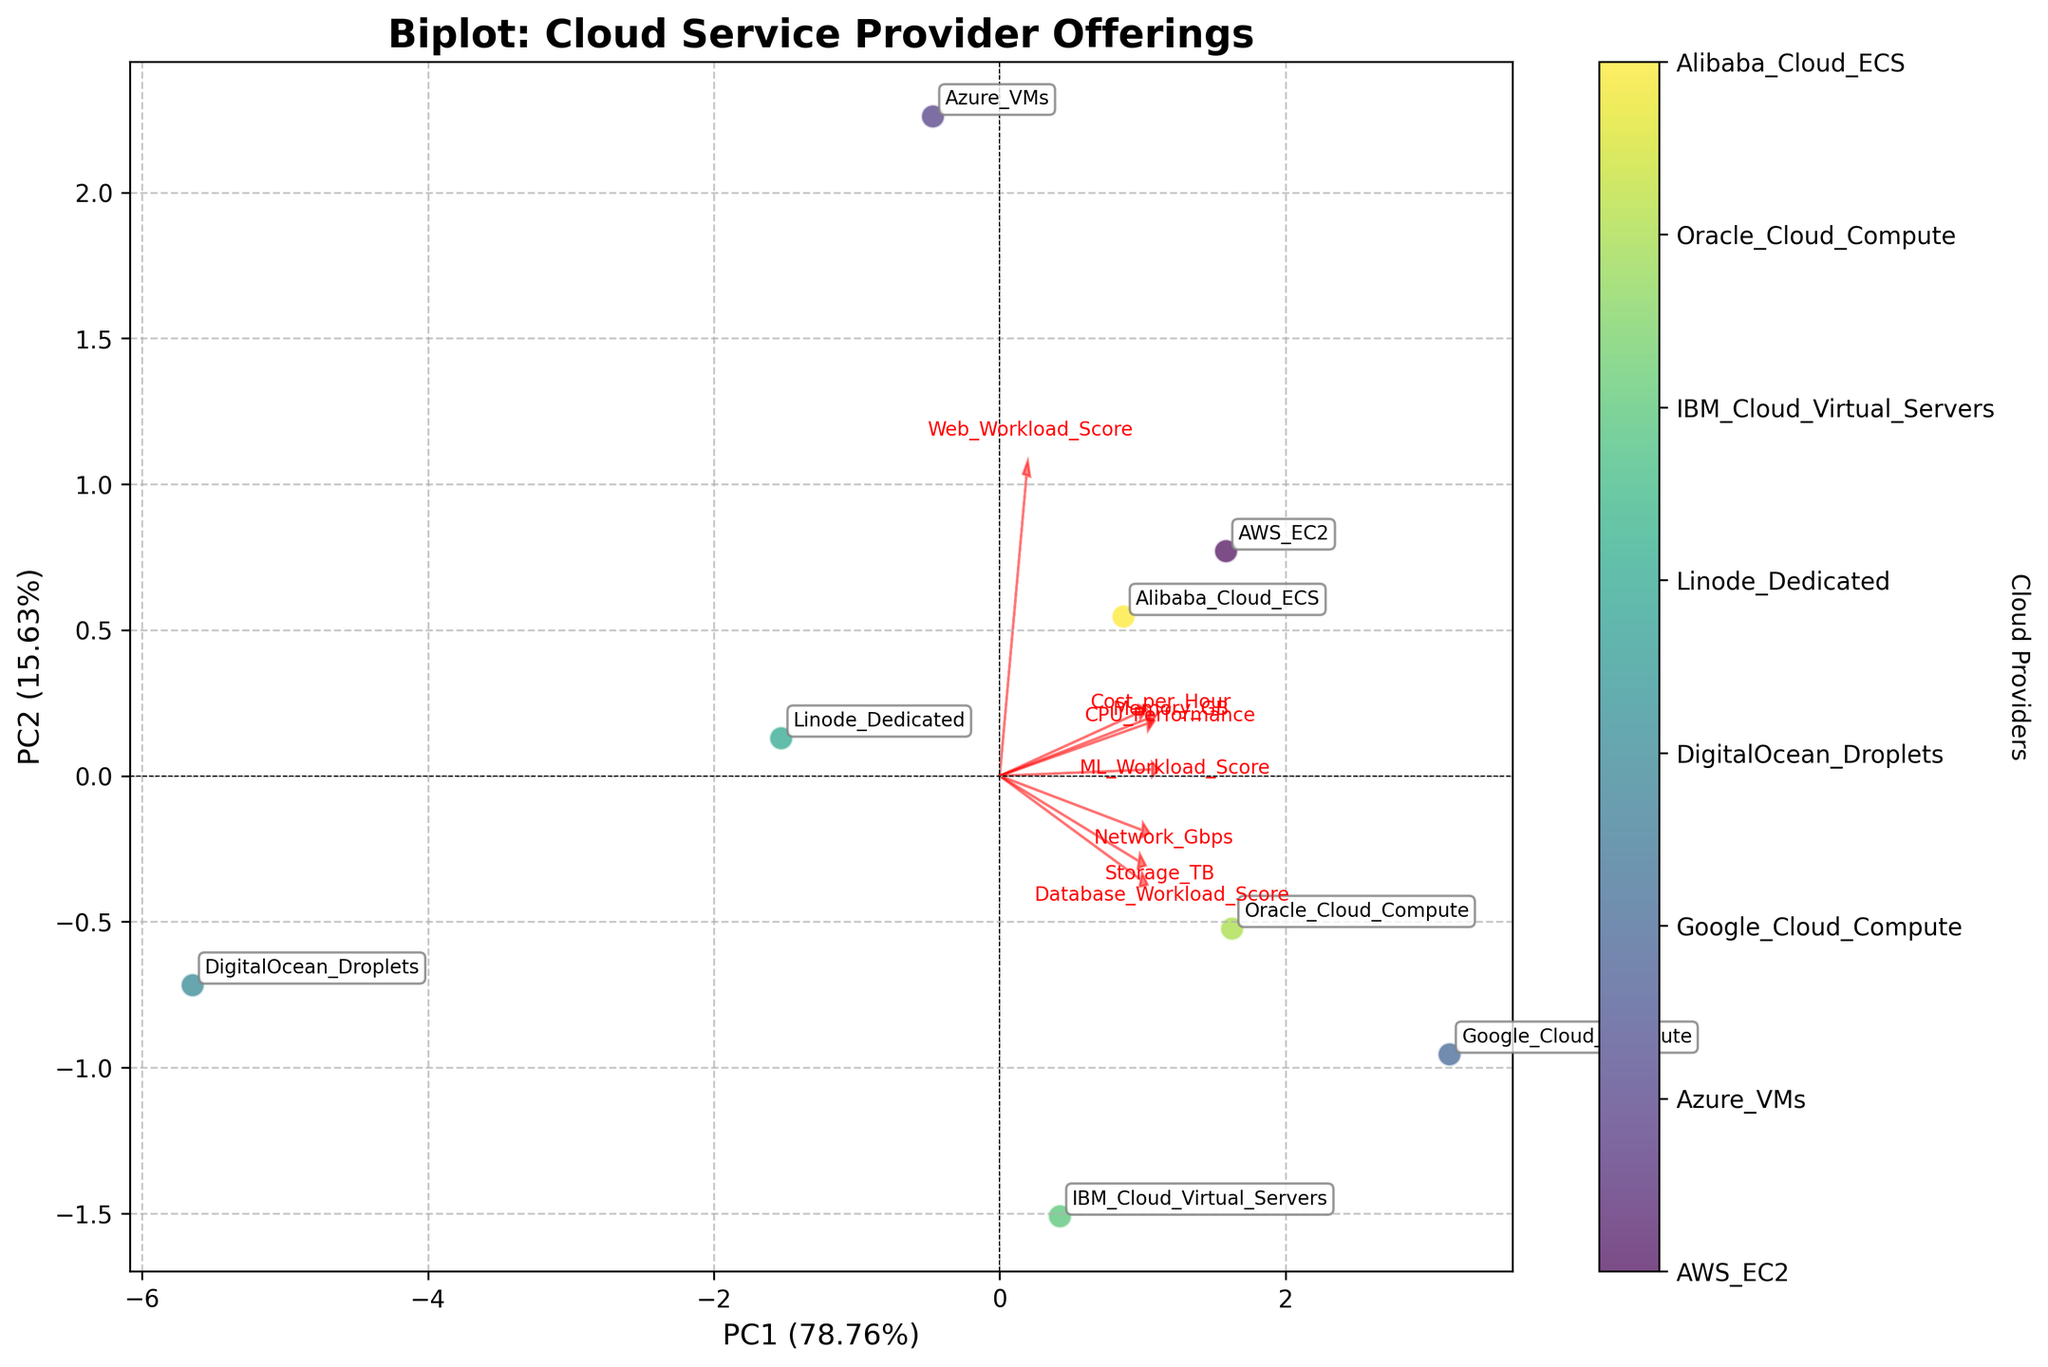What is the title of the plot? The title is typically placed at the top of the plot and is meant to give a quick summary of what the plot is about. In this case, the title is "Biplot: Cloud Service Provider Offerings," indicating that the focus is on comparing offerings from different cloud service providers.
Answer: Biplot: Cloud Service Provider Offerings How many cloud service providers are being compared in the plot? By looking at the number of names annotated in the plot for the different data points, we can count a total of 8 cloud service providers being compared.
Answer: 8 What do PC1 and PC2 represent in the plot? PC1 and PC2 are principal components, which are new variables created by the PCA technique to represent the data. The x-axis represents PC1 and the y-axis represents PC2. The proportions of variance explained by each are also shown in percentages. These principal components capture the most significant variance in the data.
Answer: Principal components Which cloud service provider has the highest value in PC1? By looking at the data points on the x-axis (PC1), we can identify the cloud service provider with the highest x-coordinate value, which indicates the highest PC1 value.
Answer: Google_Cloud_Compute Which cloud service provider has the lowest value in PC2? By looking at the data points on the y-axis (PC2), we can identify the cloud service provider with the lowest y-coordinate value, which indicates the lowest PC2 value.
Answer: DigitalOcean_Droplets Which features have the longest vectors in the biplot? The length of the vectors represents the contribution of each original feature to the principal components. By identifying the vectors that extend the furthest from the origin, we can determine which features they represent.
Answer: CPU_Performance and Memory_GB How do you interpret a cloud service provider positioned in the positive quadrant of both PC1 and PC2? A provider in the positive quadrant of both PC1 and PC2 indicates that it scores above average in the features that contribute positively to both components. For instance, if CPU_Performance and Memory_GB are highly correlated with both PC1 and PC2, the provider has high values in these features.
Answer: Above average in key features Which two providers are closest to each other in the biplot? By observing the plot, we can determine the closeness of providers by their proximity. The closer the data points are to each other, the more similar the offerings of those providers are.
Answer: Alibaba_Cloud_ECS and Azure_VMs What is the approximate explained variance of PC1? This information is found on the x-axis label, which gives the percentage of the total variance explained by the first principal component (PC1). According to the plot, PC1 explains around 50%-60% of the variance.
Answer: About 50%-60% 